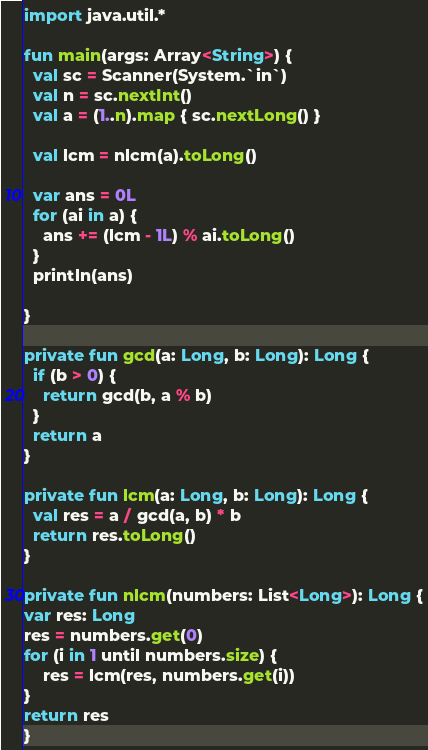Convert code to text. <code><loc_0><loc_0><loc_500><loc_500><_Kotlin_>import java.util.*

fun main(args: Array<String>) {
  val sc = Scanner(System.`in`)
  val n = sc.nextInt()
  val a = (1..n).map { sc.nextLong() }

  val lcm = nlcm(a).toLong()

  var ans = 0L
  for (ai in a) {
    ans += (lcm - 1L) % ai.toLong()
  }
  println(ans)

}

private fun gcd(a: Long, b: Long): Long {
  if (b > 0) {
    return gcd(b, a % b)
  }
  return a
}

private fun lcm(a: Long, b: Long): Long {
  val res = a / gcd(a, b) * b
  return res.toLong()
}

private fun nlcm(numbers: List<Long>): Long {
var res: Long
res = numbers.get(0)
for (i in 1 until numbers.size) {
    res = lcm(res, numbers.get(i))
}
return res
}
</code> 